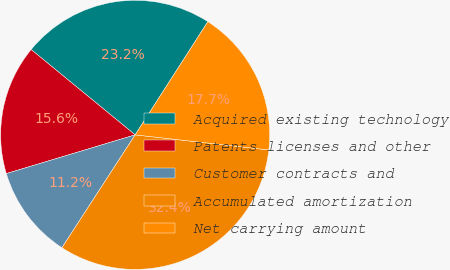<chart> <loc_0><loc_0><loc_500><loc_500><pie_chart><fcel>Acquired existing technology<fcel>Patents licenses and other<fcel>Customer contracts and<fcel>Accumulated amortization<fcel>Net carrying amount<nl><fcel>23.15%<fcel>15.58%<fcel>11.19%<fcel>32.37%<fcel>17.7%<nl></chart> 